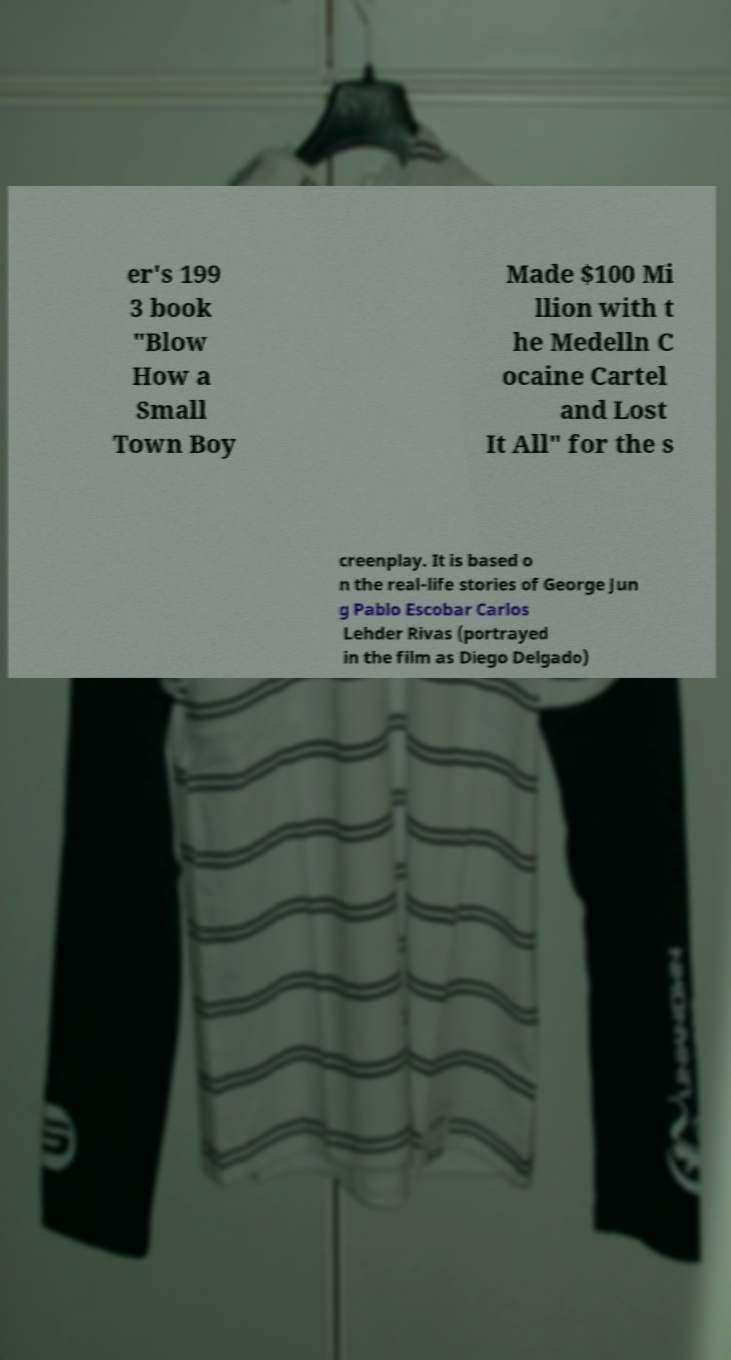I need the written content from this picture converted into text. Can you do that? er's 199 3 book "Blow How a Small Town Boy Made $100 Mi llion with t he Medelln C ocaine Cartel and Lost It All" for the s creenplay. It is based o n the real-life stories of George Jun g Pablo Escobar Carlos Lehder Rivas (portrayed in the film as Diego Delgado) 